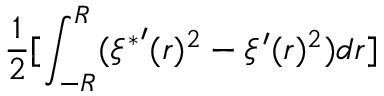Convert formula to latex. <formula><loc_0><loc_0><loc_500><loc_500>\frac { 1 } { 2 } [ \int _ { - R } ^ { R } ( { \xi ^ { * } } ^ { \prime } ( r ) ^ { 2 } - \xi ^ { \prime } ( r ) ^ { 2 } ) d r ]</formula> 